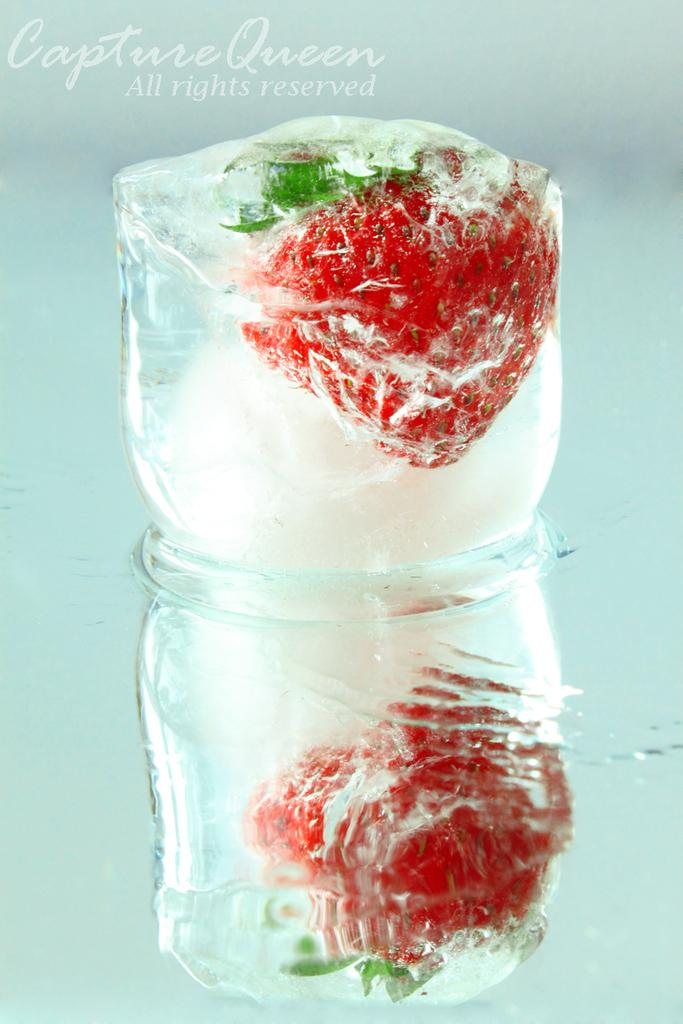What can be found in the top left corner of the image? There is text in the top left corner of the image. What is one of the objects in the image? There is an ice cube in the image. What is another object in the image? There is a strawberry in the image. What might the objects be placed on in the image? There is an object that looks like a glass table in the image. What type of pipe can be seen running through the strawberry in the image? There is no pipe present in the image, let alone running through the strawberry. 